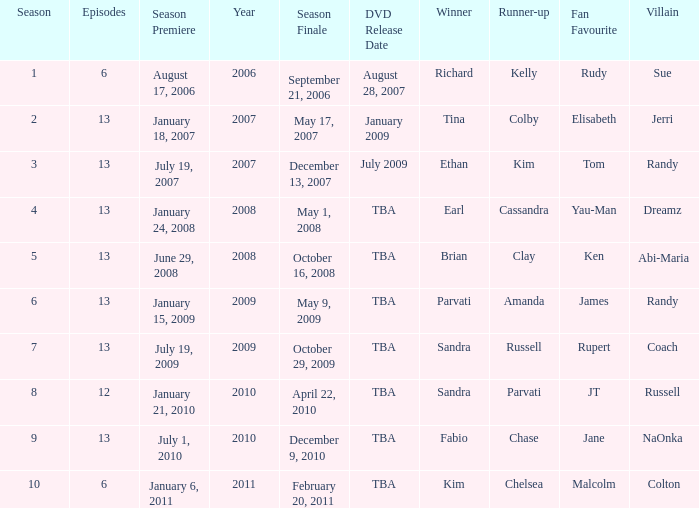Which season had fewer than 13 episodes and aired its season finale on February 20, 2011? 1.0. Parse the table in full. {'header': ['Season', 'Episodes', 'Season Premiere', 'Year', 'Season Finale', 'DVD Release Date', 'Winner', 'Runner-up', 'Fan Favourite', 'Villain '], 'rows': [['1', '6', 'August 17, 2006', '2006', 'September 21, 2006', 'August 28, 2007', 'Richard', 'Kelly', 'Rudy', 'Sue '], ['2', '13', 'January 18, 2007', '2007', 'May 17, 2007', 'January 2009', 'Tina', 'Colby', 'Elisabeth', 'Jerri '], ['3', '13', 'July 19, 2007', '2007', 'December 13, 2007', 'July 2009', 'Ethan', 'Kim', 'Tom', 'Randy '], ['4', '13', 'January 24, 2008', '2008', 'May 1, 2008', 'TBA', 'Earl', 'Cassandra', 'Yau-Man', 'Dreamz '], ['5', '13', 'June 29, 2008', '2008', 'October 16, 2008', 'TBA', 'Brian', 'Clay', 'Ken', 'Abi-Maria '], ['6', '13', 'January 15, 2009', '2009', 'May 9, 2009', 'TBA', 'Parvati', 'Amanda', 'James', 'Randy '], ['7', '13', 'July 19, 2009', '2009', 'October 29, 2009', 'TBA', 'Sandra', 'Russell', 'Rupert', 'Coach '], ['8', '12', 'January 21, 2010', '2010', 'April 22, 2010', 'TBA', 'Sandra', 'Parvati', 'JT', 'Russell '], ['9', '13', 'July 1, 2010', '2010', 'December 9, 2010', 'TBA', 'Fabio', 'Chase', 'Jane', 'NaOnka '], ['10', '6', 'January 6, 2011', '2011', 'February 20, 2011', 'TBA', 'Kim', 'Chelsea', 'Malcolm', 'Colton']]} 